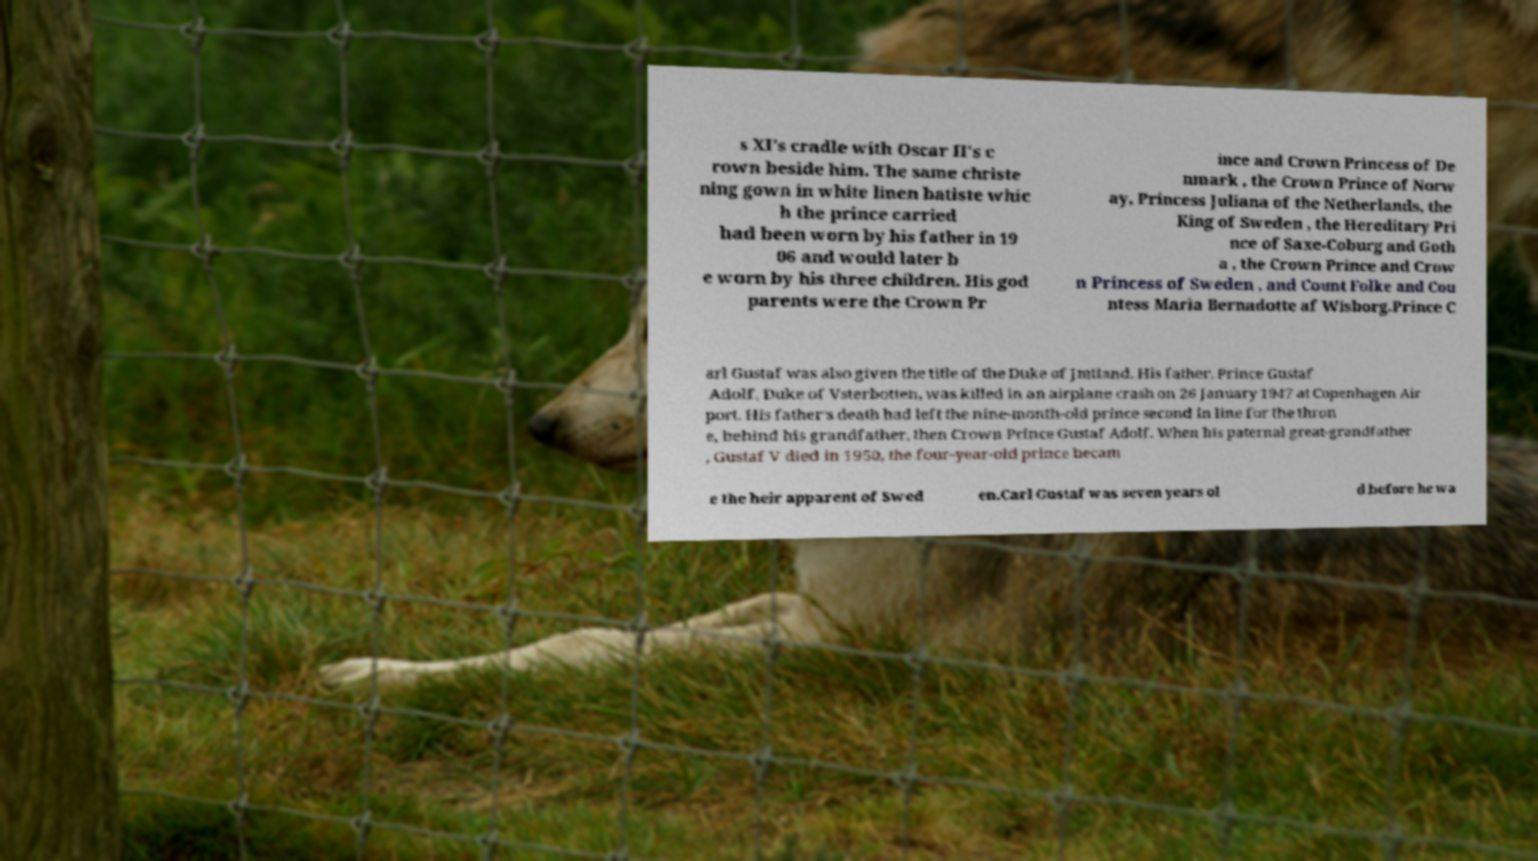For documentation purposes, I need the text within this image transcribed. Could you provide that? s XI's cradle with Oscar II's c rown beside him. The same christe ning gown in white linen batiste whic h the prince carried had been worn by his father in 19 06 and would later b e worn by his three children. His god parents were the Crown Pr ince and Crown Princess of De nmark , the Crown Prince of Norw ay, Princess Juliana of the Netherlands, the King of Sweden , the Hereditary Pri nce of Saxe-Coburg and Goth a , the Crown Prince and Crow n Princess of Sweden , and Count Folke and Cou ntess Maria Bernadotte af Wisborg.Prince C arl Gustaf was also given the title of the Duke of Jmtland. His father, Prince Gustaf Adolf, Duke of Vsterbotten, was killed in an airplane crash on 26 January 1947 at Copenhagen Air port. His father's death had left the nine-month-old prince second in line for the thron e, behind his grandfather, then Crown Prince Gustaf Adolf. When his paternal great-grandfather , Gustaf V died in 1950, the four-year-old prince becam e the heir apparent of Swed en.Carl Gustaf was seven years ol d before he wa 